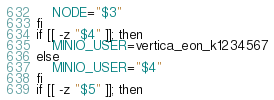<code> <loc_0><loc_0><loc_500><loc_500><_Bash_>    NODE="$3"
fi
if [[ -z "$4" ]]; then
    MINIO_USER=vertica_eon_k1234567
else
    MINIO_USER="$4"
fi
if [[ -z "$5" ]]; then</code> 